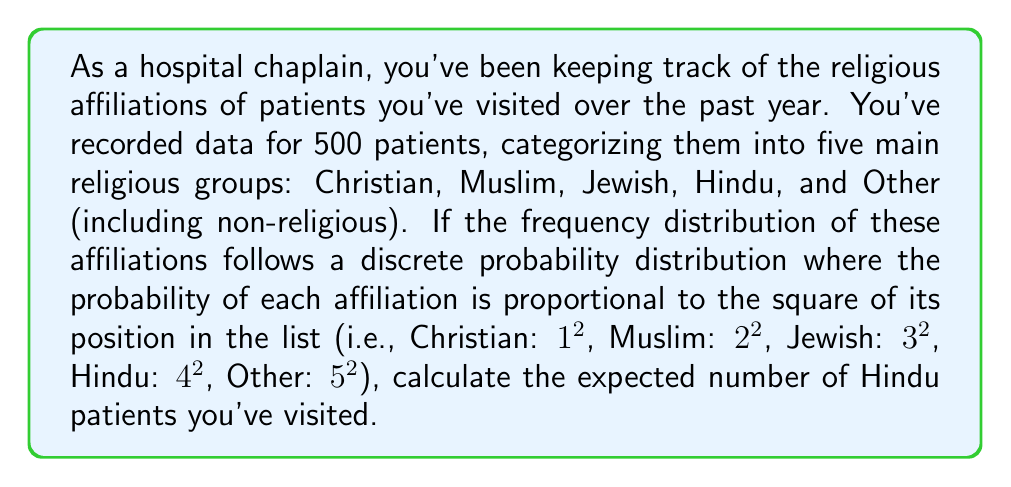Provide a solution to this math problem. To solve this problem, we need to follow these steps:

1) First, let's calculate the total sum of the squares of positions:
   $S = 1^2 + 2^2 + 3^2 + 4^2 + 5^2 = 1 + 4 + 9 + 16 + 25 = 55$

2) Now, we can calculate the probability of each affiliation:
   $P(\text{Christian}) = \frac{1^2}{55} = \frac{1}{55}$
   $P(\text{Muslim}) = \frac{2^2}{55} = \frac{4}{55}$
   $P(\text{Jewish}) = \frac{3^2}{55} = \frac{9}{55}$
   $P(\text{Hindu}) = \frac{4^2}{55} = \frac{16}{55}$
   $P(\text{Other}) = \frac{5^2}{55} = \frac{25}{55}$

3) We're interested in the expected number of Hindu patients. In a discrete probability distribution, the expected value is calculated by multiplying the number of trials by the probability of the event.

4) The number of trials is the total number of patients: 500
   The probability of a patient being Hindu is $\frac{16}{55}$

5) Therefore, the expected number of Hindu patients is:

   $E(\text{Hindu}) = 500 \cdot \frac{16}{55} = \frac{8000}{55} \approx 145.45$
Answer: The expected number of Hindu patients visited is $\frac{8000}{55}$ or approximately 145. 